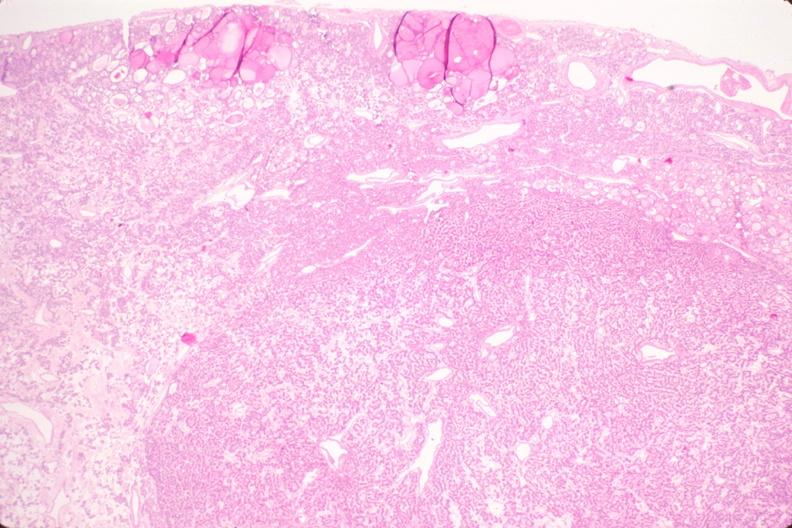does this image show thyroid, nodular hyperplasia?
Answer the question using a single word or phrase. Yes 